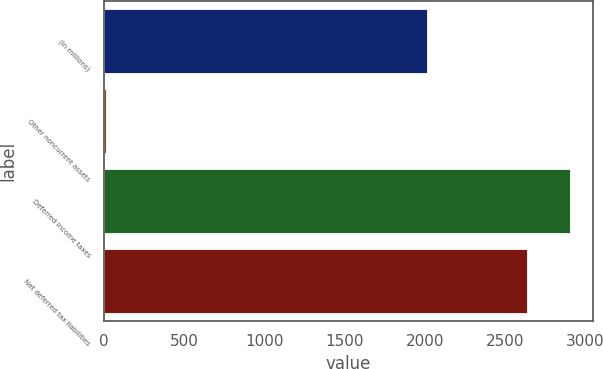<chart> <loc_0><loc_0><loc_500><loc_500><bar_chart><fcel>(In millions)<fcel>Other noncurrent assets<fcel>Deferred income taxes<fcel>Net deferred tax liabilities<nl><fcel>2017<fcel>13<fcel>2905.1<fcel>2641<nl></chart> 